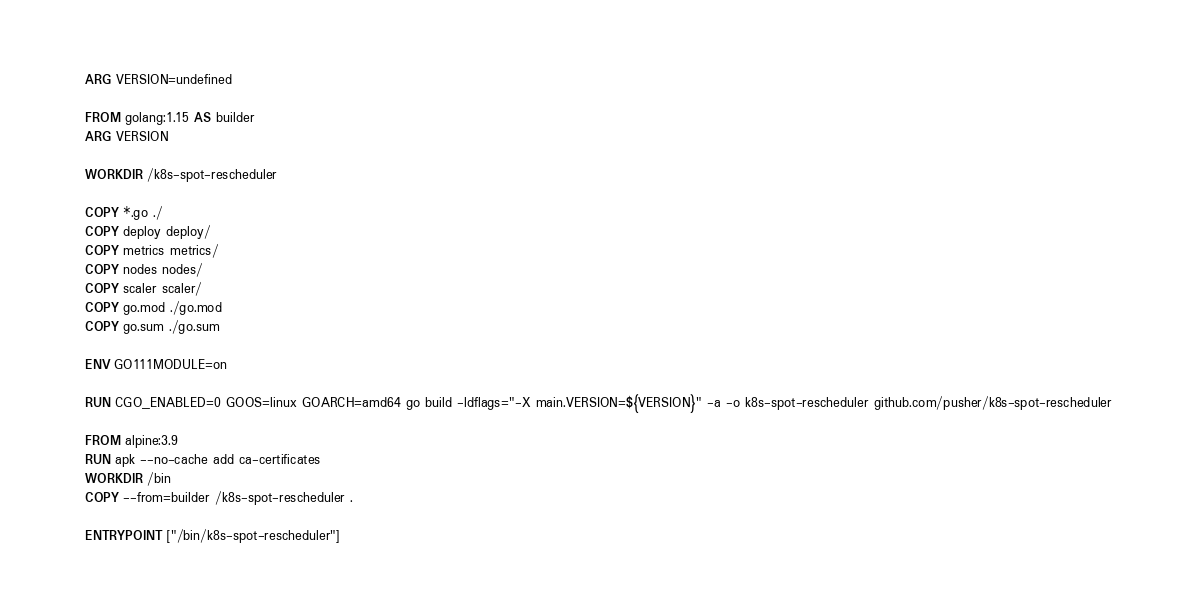<code> <loc_0><loc_0><loc_500><loc_500><_Dockerfile_>ARG VERSION=undefined

FROM golang:1.15 AS builder
ARG VERSION

WORKDIR /k8s-spot-rescheduler

COPY *.go ./
COPY deploy deploy/
COPY metrics metrics/
COPY nodes nodes/
COPY scaler scaler/
COPY go.mod ./go.mod
COPY go.sum ./go.sum

ENV GO111MODULE=on

RUN CGO_ENABLED=0 GOOS=linux GOARCH=amd64 go build -ldflags="-X main.VERSION=${VERSION}" -a -o k8s-spot-rescheduler github.com/pusher/k8s-spot-rescheduler

FROM alpine:3.9
RUN apk --no-cache add ca-certificates
WORKDIR /bin
COPY --from=builder /k8s-spot-rescheduler .

ENTRYPOINT ["/bin/k8s-spot-rescheduler"]
</code> 